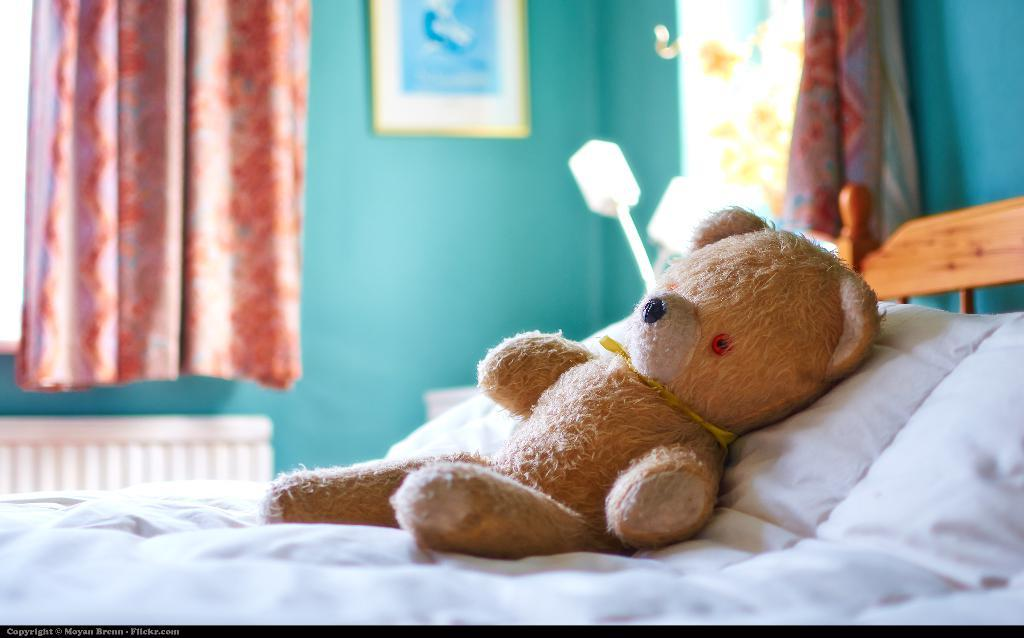What piece of furniture is present in the room? There is a bed in the room. What is placed on the bed? A teddy bear is on the bed. What feature allows light into the room? There is a window in the room. What type of window treatment is present? A curtain is hanging near the window. What source of light can be seen in the room? There is a lamp in the room. What type of gate can be seen in the image? There is no gate present in the image; it features a bed, a teddy bear, a window, a curtain, and a lamp in a room. What emotion is the teddy bear feeling in the image? Teddy bears do not have emotions, as they are inanimate objects. 